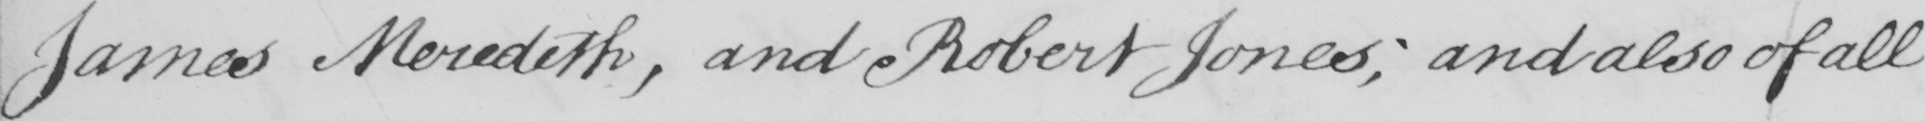Transcribe the text shown in this historical manuscript line. James Meredith , and Robert Jones ; and also of all 